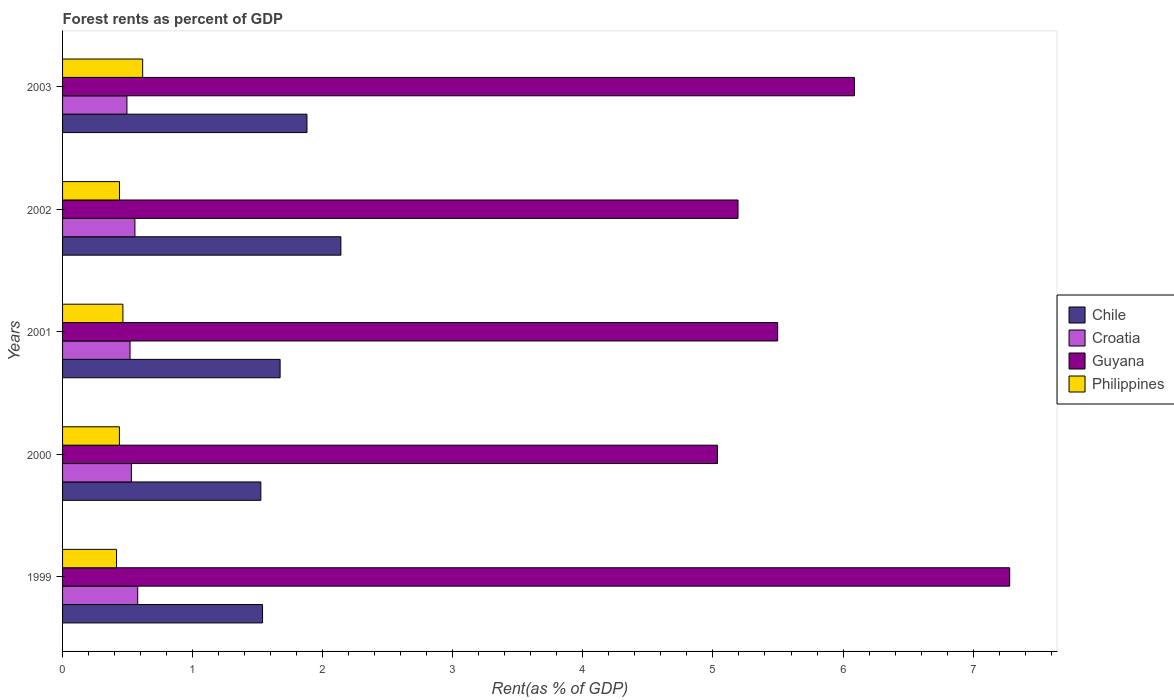Are the number of bars on each tick of the Y-axis equal?
Give a very brief answer. Yes. How many bars are there on the 3rd tick from the top?
Ensure brevity in your answer.  4. What is the forest rent in Philippines in 2002?
Your answer should be very brief. 0.44. Across all years, what is the maximum forest rent in Philippines?
Your answer should be very brief. 0.62. Across all years, what is the minimum forest rent in Philippines?
Your answer should be compact. 0.41. What is the total forest rent in Philippines in the graph?
Ensure brevity in your answer.  2.37. What is the difference between the forest rent in Chile in 2001 and that in 2003?
Offer a terse response. -0.21. What is the difference between the forest rent in Philippines in 2000 and the forest rent in Croatia in 2003?
Your answer should be very brief. -0.06. What is the average forest rent in Guyana per year?
Provide a succinct answer. 5.82. In the year 2000, what is the difference between the forest rent in Chile and forest rent in Philippines?
Your answer should be compact. 1.09. What is the ratio of the forest rent in Philippines in 2000 to that in 2001?
Provide a short and direct response. 0.94. Is the forest rent in Philippines in 2000 less than that in 2001?
Your response must be concise. Yes. Is the difference between the forest rent in Chile in 2000 and 2001 greater than the difference between the forest rent in Philippines in 2000 and 2001?
Give a very brief answer. No. What is the difference between the highest and the second highest forest rent in Guyana?
Give a very brief answer. 1.19. What is the difference between the highest and the lowest forest rent in Guyana?
Offer a very short reply. 2.25. In how many years, is the forest rent in Chile greater than the average forest rent in Chile taken over all years?
Give a very brief answer. 2. What does the 1st bar from the top in 2003 represents?
Your answer should be compact. Philippines. What does the 1st bar from the bottom in 2000 represents?
Offer a terse response. Chile. How many bars are there?
Your answer should be very brief. 20. Are all the bars in the graph horizontal?
Your answer should be very brief. Yes. How many years are there in the graph?
Your answer should be very brief. 5. What is the difference between two consecutive major ticks on the X-axis?
Provide a succinct answer. 1. How are the legend labels stacked?
Keep it short and to the point. Vertical. What is the title of the graph?
Your answer should be very brief. Forest rents as percent of GDP. Does "Lesotho" appear as one of the legend labels in the graph?
Provide a succinct answer. No. What is the label or title of the X-axis?
Provide a succinct answer. Rent(as % of GDP). What is the label or title of the Y-axis?
Make the answer very short. Years. What is the Rent(as % of GDP) in Chile in 1999?
Make the answer very short. 1.54. What is the Rent(as % of GDP) in Croatia in 1999?
Make the answer very short. 0.58. What is the Rent(as % of GDP) in Guyana in 1999?
Keep it short and to the point. 7.28. What is the Rent(as % of GDP) in Philippines in 1999?
Offer a terse response. 0.41. What is the Rent(as % of GDP) of Chile in 2000?
Provide a short and direct response. 1.52. What is the Rent(as % of GDP) of Croatia in 2000?
Make the answer very short. 0.53. What is the Rent(as % of GDP) in Guyana in 2000?
Offer a very short reply. 5.03. What is the Rent(as % of GDP) in Philippines in 2000?
Provide a short and direct response. 0.44. What is the Rent(as % of GDP) of Chile in 2001?
Provide a short and direct response. 1.67. What is the Rent(as % of GDP) of Croatia in 2001?
Offer a very short reply. 0.52. What is the Rent(as % of GDP) in Guyana in 2001?
Offer a terse response. 5.5. What is the Rent(as % of GDP) in Philippines in 2001?
Provide a short and direct response. 0.46. What is the Rent(as % of GDP) in Chile in 2002?
Your response must be concise. 2.14. What is the Rent(as % of GDP) of Croatia in 2002?
Keep it short and to the point. 0.56. What is the Rent(as % of GDP) of Guyana in 2002?
Give a very brief answer. 5.19. What is the Rent(as % of GDP) of Philippines in 2002?
Ensure brevity in your answer.  0.44. What is the Rent(as % of GDP) of Chile in 2003?
Make the answer very short. 1.88. What is the Rent(as % of GDP) in Croatia in 2003?
Your answer should be compact. 0.49. What is the Rent(as % of GDP) of Guyana in 2003?
Make the answer very short. 6.09. What is the Rent(as % of GDP) of Philippines in 2003?
Offer a very short reply. 0.62. Across all years, what is the maximum Rent(as % of GDP) of Chile?
Keep it short and to the point. 2.14. Across all years, what is the maximum Rent(as % of GDP) of Croatia?
Provide a succinct answer. 0.58. Across all years, what is the maximum Rent(as % of GDP) in Guyana?
Your response must be concise. 7.28. Across all years, what is the maximum Rent(as % of GDP) of Philippines?
Offer a very short reply. 0.62. Across all years, what is the minimum Rent(as % of GDP) of Chile?
Your response must be concise. 1.52. Across all years, what is the minimum Rent(as % of GDP) of Croatia?
Provide a short and direct response. 0.49. Across all years, what is the minimum Rent(as % of GDP) in Guyana?
Offer a very short reply. 5.03. Across all years, what is the minimum Rent(as % of GDP) in Philippines?
Offer a very short reply. 0.41. What is the total Rent(as % of GDP) of Chile in the graph?
Your answer should be very brief. 8.75. What is the total Rent(as % of GDP) in Croatia in the graph?
Offer a terse response. 2.68. What is the total Rent(as % of GDP) of Guyana in the graph?
Ensure brevity in your answer.  29.09. What is the total Rent(as % of GDP) of Philippines in the graph?
Your response must be concise. 2.37. What is the difference between the Rent(as % of GDP) of Chile in 1999 and that in 2000?
Make the answer very short. 0.01. What is the difference between the Rent(as % of GDP) in Croatia in 1999 and that in 2000?
Keep it short and to the point. 0.05. What is the difference between the Rent(as % of GDP) of Guyana in 1999 and that in 2000?
Your answer should be very brief. 2.25. What is the difference between the Rent(as % of GDP) of Philippines in 1999 and that in 2000?
Your answer should be very brief. -0.02. What is the difference between the Rent(as % of GDP) of Chile in 1999 and that in 2001?
Offer a very short reply. -0.14. What is the difference between the Rent(as % of GDP) of Croatia in 1999 and that in 2001?
Your answer should be very brief. 0.06. What is the difference between the Rent(as % of GDP) of Guyana in 1999 and that in 2001?
Make the answer very short. 1.78. What is the difference between the Rent(as % of GDP) in Philippines in 1999 and that in 2001?
Offer a very short reply. -0.05. What is the difference between the Rent(as % of GDP) of Chile in 1999 and that in 2002?
Make the answer very short. -0.6. What is the difference between the Rent(as % of GDP) in Croatia in 1999 and that in 2002?
Provide a short and direct response. 0.02. What is the difference between the Rent(as % of GDP) of Guyana in 1999 and that in 2002?
Give a very brief answer. 2.09. What is the difference between the Rent(as % of GDP) in Philippines in 1999 and that in 2002?
Your answer should be very brief. -0.02. What is the difference between the Rent(as % of GDP) in Chile in 1999 and that in 2003?
Provide a succinct answer. -0.34. What is the difference between the Rent(as % of GDP) of Croatia in 1999 and that in 2003?
Your answer should be very brief. 0.08. What is the difference between the Rent(as % of GDP) of Guyana in 1999 and that in 2003?
Your answer should be very brief. 1.19. What is the difference between the Rent(as % of GDP) of Philippines in 1999 and that in 2003?
Keep it short and to the point. -0.2. What is the difference between the Rent(as % of GDP) of Chile in 2000 and that in 2001?
Make the answer very short. -0.15. What is the difference between the Rent(as % of GDP) of Croatia in 2000 and that in 2001?
Ensure brevity in your answer.  0.01. What is the difference between the Rent(as % of GDP) in Guyana in 2000 and that in 2001?
Give a very brief answer. -0.46. What is the difference between the Rent(as % of GDP) in Philippines in 2000 and that in 2001?
Make the answer very short. -0.03. What is the difference between the Rent(as % of GDP) of Chile in 2000 and that in 2002?
Your answer should be compact. -0.62. What is the difference between the Rent(as % of GDP) of Croatia in 2000 and that in 2002?
Ensure brevity in your answer.  -0.03. What is the difference between the Rent(as % of GDP) of Guyana in 2000 and that in 2002?
Offer a very short reply. -0.16. What is the difference between the Rent(as % of GDP) of Philippines in 2000 and that in 2002?
Your response must be concise. -0. What is the difference between the Rent(as % of GDP) of Chile in 2000 and that in 2003?
Give a very brief answer. -0.35. What is the difference between the Rent(as % of GDP) in Croatia in 2000 and that in 2003?
Keep it short and to the point. 0.03. What is the difference between the Rent(as % of GDP) in Guyana in 2000 and that in 2003?
Your answer should be very brief. -1.05. What is the difference between the Rent(as % of GDP) in Philippines in 2000 and that in 2003?
Your response must be concise. -0.18. What is the difference between the Rent(as % of GDP) in Chile in 2001 and that in 2002?
Your answer should be compact. -0.47. What is the difference between the Rent(as % of GDP) of Croatia in 2001 and that in 2002?
Offer a terse response. -0.04. What is the difference between the Rent(as % of GDP) in Guyana in 2001 and that in 2002?
Give a very brief answer. 0.3. What is the difference between the Rent(as % of GDP) of Philippines in 2001 and that in 2002?
Offer a very short reply. 0.03. What is the difference between the Rent(as % of GDP) in Chile in 2001 and that in 2003?
Make the answer very short. -0.21. What is the difference between the Rent(as % of GDP) in Croatia in 2001 and that in 2003?
Give a very brief answer. 0.02. What is the difference between the Rent(as % of GDP) in Guyana in 2001 and that in 2003?
Keep it short and to the point. -0.59. What is the difference between the Rent(as % of GDP) in Philippines in 2001 and that in 2003?
Your answer should be very brief. -0.15. What is the difference between the Rent(as % of GDP) in Chile in 2002 and that in 2003?
Provide a short and direct response. 0.26. What is the difference between the Rent(as % of GDP) in Croatia in 2002 and that in 2003?
Provide a short and direct response. 0.06. What is the difference between the Rent(as % of GDP) in Guyana in 2002 and that in 2003?
Make the answer very short. -0.89. What is the difference between the Rent(as % of GDP) of Philippines in 2002 and that in 2003?
Keep it short and to the point. -0.18. What is the difference between the Rent(as % of GDP) in Chile in 1999 and the Rent(as % of GDP) in Croatia in 2000?
Make the answer very short. 1.01. What is the difference between the Rent(as % of GDP) of Chile in 1999 and the Rent(as % of GDP) of Guyana in 2000?
Make the answer very short. -3.5. What is the difference between the Rent(as % of GDP) of Chile in 1999 and the Rent(as % of GDP) of Philippines in 2000?
Offer a terse response. 1.1. What is the difference between the Rent(as % of GDP) in Croatia in 1999 and the Rent(as % of GDP) in Guyana in 2000?
Provide a short and direct response. -4.46. What is the difference between the Rent(as % of GDP) in Croatia in 1999 and the Rent(as % of GDP) in Philippines in 2000?
Your answer should be compact. 0.14. What is the difference between the Rent(as % of GDP) in Guyana in 1999 and the Rent(as % of GDP) in Philippines in 2000?
Offer a very short reply. 6.84. What is the difference between the Rent(as % of GDP) of Chile in 1999 and the Rent(as % of GDP) of Croatia in 2001?
Ensure brevity in your answer.  1.02. What is the difference between the Rent(as % of GDP) in Chile in 1999 and the Rent(as % of GDP) in Guyana in 2001?
Make the answer very short. -3.96. What is the difference between the Rent(as % of GDP) of Chile in 1999 and the Rent(as % of GDP) of Philippines in 2001?
Give a very brief answer. 1.07. What is the difference between the Rent(as % of GDP) of Croatia in 1999 and the Rent(as % of GDP) of Guyana in 2001?
Your answer should be very brief. -4.92. What is the difference between the Rent(as % of GDP) of Croatia in 1999 and the Rent(as % of GDP) of Philippines in 2001?
Make the answer very short. 0.11. What is the difference between the Rent(as % of GDP) in Guyana in 1999 and the Rent(as % of GDP) in Philippines in 2001?
Keep it short and to the point. 6.82. What is the difference between the Rent(as % of GDP) in Chile in 1999 and the Rent(as % of GDP) in Croatia in 2002?
Offer a terse response. 0.98. What is the difference between the Rent(as % of GDP) in Chile in 1999 and the Rent(as % of GDP) in Guyana in 2002?
Offer a very short reply. -3.66. What is the difference between the Rent(as % of GDP) of Chile in 1999 and the Rent(as % of GDP) of Philippines in 2002?
Offer a very short reply. 1.1. What is the difference between the Rent(as % of GDP) in Croatia in 1999 and the Rent(as % of GDP) in Guyana in 2002?
Provide a short and direct response. -4.61. What is the difference between the Rent(as % of GDP) in Croatia in 1999 and the Rent(as % of GDP) in Philippines in 2002?
Provide a succinct answer. 0.14. What is the difference between the Rent(as % of GDP) in Guyana in 1999 and the Rent(as % of GDP) in Philippines in 2002?
Your answer should be very brief. 6.84. What is the difference between the Rent(as % of GDP) in Chile in 1999 and the Rent(as % of GDP) in Croatia in 2003?
Give a very brief answer. 1.04. What is the difference between the Rent(as % of GDP) in Chile in 1999 and the Rent(as % of GDP) in Guyana in 2003?
Ensure brevity in your answer.  -4.55. What is the difference between the Rent(as % of GDP) of Chile in 1999 and the Rent(as % of GDP) of Philippines in 2003?
Your answer should be compact. 0.92. What is the difference between the Rent(as % of GDP) of Croatia in 1999 and the Rent(as % of GDP) of Guyana in 2003?
Your response must be concise. -5.51. What is the difference between the Rent(as % of GDP) of Croatia in 1999 and the Rent(as % of GDP) of Philippines in 2003?
Offer a very short reply. -0.04. What is the difference between the Rent(as % of GDP) of Guyana in 1999 and the Rent(as % of GDP) of Philippines in 2003?
Offer a very short reply. 6.67. What is the difference between the Rent(as % of GDP) in Chile in 2000 and the Rent(as % of GDP) in Croatia in 2001?
Your answer should be compact. 1.01. What is the difference between the Rent(as % of GDP) in Chile in 2000 and the Rent(as % of GDP) in Guyana in 2001?
Provide a succinct answer. -3.97. What is the difference between the Rent(as % of GDP) of Chile in 2000 and the Rent(as % of GDP) of Philippines in 2001?
Your response must be concise. 1.06. What is the difference between the Rent(as % of GDP) of Croatia in 2000 and the Rent(as % of GDP) of Guyana in 2001?
Offer a terse response. -4.97. What is the difference between the Rent(as % of GDP) in Croatia in 2000 and the Rent(as % of GDP) in Philippines in 2001?
Provide a succinct answer. 0.07. What is the difference between the Rent(as % of GDP) in Guyana in 2000 and the Rent(as % of GDP) in Philippines in 2001?
Offer a very short reply. 4.57. What is the difference between the Rent(as % of GDP) in Chile in 2000 and the Rent(as % of GDP) in Croatia in 2002?
Provide a succinct answer. 0.97. What is the difference between the Rent(as % of GDP) of Chile in 2000 and the Rent(as % of GDP) of Guyana in 2002?
Provide a succinct answer. -3.67. What is the difference between the Rent(as % of GDP) in Chile in 2000 and the Rent(as % of GDP) in Philippines in 2002?
Offer a terse response. 1.09. What is the difference between the Rent(as % of GDP) in Croatia in 2000 and the Rent(as % of GDP) in Guyana in 2002?
Your answer should be very brief. -4.66. What is the difference between the Rent(as % of GDP) of Croatia in 2000 and the Rent(as % of GDP) of Philippines in 2002?
Ensure brevity in your answer.  0.09. What is the difference between the Rent(as % of GDP) in Guyana in 2000 and the Rent(as % of GDP) in Philippines in 2002?
Your answer should be very brief. 4.6. What is the difference between the Rent(as % of GDP) of Chile in 2000 and the Rent(as % of GDP) of Croatia in 2003?
Provide a short and direct response. 1.03. What is the difference between the Rent(as % of GDP) in Chile in 2000 and the Rent(as % of GDP) in Guyana in 2003?
Your answer should be compact. -4.56. What is the difference between the Rent(as % of GDP) of Chile in 2000 and the Rent(as % of GDP) of Philippines in 2003?
Your answer should be very brief. 0.91. What is the difference between the Rent(as % of GDP) in Croatia in 2000 and the Rent(as % of GDP) in Guyana in 2003?
Ensure brevity in your answer.  -5.56. What is the difference between the Rent(as % of GDP) of Croatia in 2000 and the Rent(as % of GDP) of Philippines in 2003?
Your response must be concise. -0.09. What is the difference between the Rent(as % of GDP) of Guyana in 2000 and the Rent(as % of GDP) of Philippines in 2003?
Your answer should be very brief. 4.42. What is the difference between the Rent(as % of GDP) of Chile in 2001 and the Rent(as % of GDP) of Croatia in 2002?
Provide a succinct answer. 1.12. What is the difference between the Rent(as % of GDP) in Chile in 2001 and the Rent(as % of GDP) in Guyana in 2002?
Offer a terse response. -3.52. What is the difference between the Rent(as % of GDP) in Chile in 2001 and the Rent(as % of GDP) in Philippines in 2002?
Make the answer very short. 1.23. What is the difference between the Rent(as % of GDP) of Croatia in 2001 and the Rent(as % of GDP) of Guyana in 2002?
Offer a terse response. -4.67. What is the difference between the Rent(as % of GDP) in Croatia in 2001 and the Rent(as % of GDP) in Philippines in 2002?
Provide a succinct answer. 0.08. What is the difference between the Rent(as % of GDP) in Guyana in 2001 and the Rent(as % of GDP) in Philippines in 2002?
Make the answer very short. 5.06. What is the difference between the Rent(as % of GDP) in Chile in 2001 and the Rent(as % of GDP) in Croatia in 2003?
Give a very brief answer. 1.18. What is the difference between the Rent(as % of GDP) of Chile in 2001 and the Rent(as % of GDP) of Guyana in 2003?
Provide a short and direct response. -4.41. What is the difference between the Rent(as % of GDP) of Chile in 2001 and the Rent(as % of GDP) of Philippines in 2003?
Your answer should be compact. 1.06. What is the difference between the Rent(as % of GDP) in Croatia in 2001 and the Rent(as % of GDP) in Guyana in 2003?
Provide a short and direct response. -5.57. What is the difference between the Rent(as % of GDP) of Croatia in 2001 and the Rent(as % of GDP) of Philippines in 2003?
Give a very brief answer. -0.1. What is the difference between the Rent(as % of GDP) of Guyana in 2001 and the Rent(as % of GDP) of Philippines in 2003?
Provide a short and direct response. 4.88. What is the difference between the Rent(as % of GDP) of Chile in 2002 and the Rent(as % of GDP) of Croatia in 2003?
Offer a terse response. 1.64. What is the difference between the Rent(as % of GDP) of Chile in 2002 and the Rent(as % of GDP) of Guyana in 2003?
Keep it short and to the point. -3.95. What is the difference between the Rent(as % of GDP) in Chile in 2002 and the Rent(as % of GDP) in Philippines in 2003?
Your response must be concise. 1.52. What is the difference between the Rent(as % of GDP) in Croatia in 2002 and the Rent(as % of GDP) in Guyana in 2003?
Ensure brevity in your answer.  -5.53. What is the difference between the Rent(as % of GDP) of Croatia in 2002 and the Rent(as % of GDP) of Philippines in 2003?
Make the answer very short. -0.06. What is the difference between the Rent(as % of GDP) in Guyana in 2002 and the Rent(as % of GDP) in Philippines in 2003?
Provide a succinct answer. 4.58. What is the average Rent(as % of GDP) of Chile per year?
Make the answer very short. 1.75. What is the average Rent(as % of GDP) in Croatia per year?
Offer a very short reply. 0.54. What is the average Rent(as % of GDP) of Guyana per year?
Your answer should be very brief. 5.82. What is the average Rent(as % of GDP) in Philippines per year?
Your answer should be very brief. 0.47. In the year 1999, what is the difference between the Rent(as % of GDP) in Chile and Rent(as % of GDP) in Croatia?
Ensure brevity in your answer.  0.96. In the year 1999, what is the difference between the Rent(as % of GDP) in Chile and Rent(as % of GDP) in Guyana?
Your answer should be compact. -5.74. In the year 1999, what is the difference between the Rent(as % of GDP) in Chile and Rent(as % of GDP) in Philippines?
Give a very brief answer. 1.12. In the year 1999, what is the difference between the Rent(as % of GDP) of Croatia and Rent(as % of GDP) of Guyana?
Ensure brevity in your answer.  -6.7. In the year 1999, what is the difference between the Rent(as % of GDP) in Croatia and Rent(as % of GDP) in Philippines?
Your answer should be very brief. 0.16. In the year 1999, what is the difference between the Rent(as % of GDP) in Guyana and Rent(as % of GDP) in Philippines?
Your answer should be compact. 6.87. In the year 2000, what is the difference between the Rent(as % of GDP) of Chile and Rent(as % of GDP) of Guyana?
Give a very brief answer. -3.51. In the year 2000, what is the difference between the Rent(as % of GDP) of Chile and Rent(as % of GDP) of Philippines?
Provide a succinct answer. 1.09. In the year 2000, what is the difference between the Rent(as % of GDP) of Croatia and Rent(as % of GDP) of Guyana?
Make the answer very short. -4.51. In the year 2000, what is the difference between the Rent(as % of GDP) of Croatia and Rent(as % of GDP) of Philippines?
Make the answer very short. 0.09. In the year 2000, what is the difference between the Rent(as % of GDP) of Guyana and Rent(as % of GDP) of Philippines?
Provide a succinct answer. 4.6. In the year 2001, what is the difference between the Rent(as % of GDP) in Chile and Rent(as % of GDP) in Croatia?
Offer a very short reply. 1.15. In the year 2001, what is the difference between the Rent(as % of GDP) in Chile and Rent(as % of GDP) in Guyana?
Your response must be concise. -3.83. In the year 2001, what is the difference between the Rent(as % of GDP) in Chile and Rent(as % of GDP) in Philippines?
Your response must be concise. 1.21. In the year 2001, what is the difference between the Rent(as % of GDP) in Croatia and Rent(as % of GDP) in Guyana?
Provide a short and direct response. -4.98. In the year 2001, what is the difference between the Rent(as % of GDP) of Croatia and Rent(as % of GDP) of Philippines?
Give a very brief answer. 0.05. In the year 2001, what is the difference between the Rent(as % of GDP) in Guyana and Rent(as % of GDP) in Philippines?
Keep it short and to the point. 5.03. In the year 2002, what is the difference between the Rent(as % of GDP) in Chile and Rent(as % of GDP) in Croatia?
Your answer should be very brief. 1.58. In the year 2002, what is the difference between the Rent(as % of GDP) in Chile and Rent(as % of GDP) in Guyana?
Provide a short and direct response. -3.05. In the year 2002, what is the difference between the Rent(as % of GDP) in Chile and Rent(as % of GDP) in Philippines?
Keep it short and to the point. 1.7. In the year 2002, what is the difference between the Rent(as % of GDP) of Croatia and Rent(as % of GDP) of Guyana?
Your answer should be compact. -4.64. In the year 2002, what is the difference between the Rent(as % of GDP) in Croatia and Rent(as % of GDP) in Philippines?
Give a very brief answer. 0.12. In the year 2002, what is the difference between the Rent(as % of GDP) in Guyana and Rent(as % of GDP) in Philippines?
Your answer should be very brief. 4.75. In the year 2003, what is the difference between the Rent(as % of GDP) of Chile and Rent(as % of GDP) of Croatia?
Provide a short and direct response. 1.38. In the year 2003, what is the difference between the Rent(as % of GDP) of Chile and Rent(as % of GDP) of Guyana?
Make the answer very short. -4.21. In the year 2003, what is the difference between the Rent(as % of GDP) of Chile and Rent(as % of GDP) of Philippines?
Ensure brevity in your answer.  1.26. In the year 2003, what is the difference between the Rent(as % of GDP) in Croatia and Rent(as % of GDP) in Guyana?
Give a very brief answer. -5.59. In the year 2003, what is the difference between the Rent(as % of GDP) in Croatia and Rent(as % of GDP) in Philippines?
Provide a succinct answer. -0.12. In the year 2003, what is the difference between the Rent(as % of GDP) in Guyana and Rent(as % of GDP) in Philippines?
Offer a terse response. 5.47. What is the ratio of the Rent(as % of GDP) in Chile in 1999 to that in 2000?
Ensure brevity in your answer.  1.01. What is the ratio of the Rent(as % of GDP) of Croatia in 1999 to that in 2000?
Your answer should be compact. 1.09. What is the ratio of the Rent(as % of GDP) of Guyana in 1999 to that in 2000?
Keep it short and to the point. 1.45. What is the ratio of the Rent(as % of GDP) of Philippines in 1999 to that in 2000?
Offer a terse response. 0.95. What is the ratio of the Rent(as % of GDP) in Chile in 1999 to that in 2001?
Your response must be concise. 0.92. What is the ratio of the Rent(as % of GDP) in Croatia in 1999 to that in 2001?
Keep it short and to the point. 1.11. What is the ratio of the Rent(as % of GDP) in Guyana in 1999 to that in 2001?
Ensure brevity in your answer.  1.32. What is the ratio of the Rent(as % of GDP) in Philippines in 1999 to that in 2001?
Offer a very short reply. 0.89. What is the ratio of the Rent(as % of GDP) in Chile in 1999 to that in 2002?
Offer a very short reply. 0.72. What is the ratio of the Rent(as % of GDP) in Croatia in 1999 to that in 2002?
Provide a short and direct response. 1.04. What is the ratio of the Rent(as % of GDP) of Guyana in 1999 to that in 2002?
Your answer should be very brief. 1.4. What is the ratio of the Rent(as % of GDP) of Philippines in 1999 to that in 2002?
Provide a succinct answer. 0.95. What is the ratio of the Rent(as % of GDP) of Chile in 1999 to that in 2003?
Ensure brevity in your answer.  0.82. What is the ratio of the Rent(as % of GDP) in Croatia in 1999 to that in 2003?
Give a very brief answer. 1.17. What is the ratio of the Rent(as % of GDP) in Guyana in 1999 to that in 2003?
Ensure brevity in your answer.  1.2. What is the ratio of the Rent(as % of GDP) in Philippines in 1999 to that in 2003?
Ensure brevity in your answer.  0.67. What is the ratio of the Rent(as % of GDP) in Chile in 2000 to that in 2001?
Make the answer very short. 0.91. What is the ratio of the Rent(as % of GDP) in Croatia in 2000 to that in 2001?
Provide a succinct answer. 1.02. What is the ratio of the Rent(as % of GDP) of Guyana in 2000 to that in 2001?
Your response must be concise. 0.92. What is the ratio of the Rent(as % of GDP) in Philippines in 2000 to that in 2001?
Ensure brevity in your answer.  0.94. What is the ratio of the Rent(as % of GDP) in Chile in 2000 to that in 2002?
Keep it short and to the point. 0.71. What is the ratio of the Rent(as % of GDP) of Croatia in 2000 to that in 2002?
Provide a succinct answer. 0.95. What is the ratio of the Rent(as % of GDP) in Guyana in 2000 to that in 2002?
Give a very brief answer. 0.97. What is the ratio of the Rent(as % of GDP) of Chile in 2000 to that in 2003?
Give a very brief answer. 0.81. What is the ratio of the Rent(as % of GDP) in Croatia in 2000 to that in 2003?
Offer a terse response. 1.07. What is the ratio of the Rent(as % of GDP) in Guyana in 2000 to that in 2003?
Provide a short and direct response. 0.83. What is the ratio of the Rent(as % of GDP) of Philippines in 2000 to that in 2003?
Provide a short and direct response. 0.71. What is the ratio of the Rent(as % of GDP) of Chile in 2001 to that in 2002?
Your answer should be compact. 0.78. What is the ratio of the Rent(as % of GDP) in Croatia in 2001 to that in 2002?
Make the answer very short. 0.93. What is the ratio of the Rent(as % of GDP) in Guyana in 2001 to that in 2002?
Your answer should be compact. 1.06. What is the ratio of the Rent(as % of GDP) in Philippines in 2001 to that in 2002?
Give a very brief answer. 1.06. What is the ratio of the Rent(as % of GDP) of Chile in 2001 to that in 2003?
Keep it short and to the point. 0.89. What is the ratio of the Rent(as % of GDP) in Croatia in 2001 to that in 2003?
Your response must be concise. 1.05. What is the ratio of the Rent(as % of GDP) in Guyana in 2001 to that in 2003?
Offer a terse response. 0.9. What is the ratio of the Rent(as % of GDP) in Philippines in 2001 to that in 2003?
Provide a succinct answer. 0.75. What is the ratio of the Rent(as % of GDP) of Chile in 2002 to that in 2003?
Keep it short and to the point. 1.14. What is the ratio of the Rent(as % of GDP) of Croatia in 2002 to that in 2003?
Your answer should be very brief. 1.12. What is the ratio of the Rent(as % of GDP) in Guyana in 2002 to that in 2003?
Give a very brief answer. 0.85. What is the ratio of the Rent(as % of GDP) in Philippines in 2002 to that in 2003?
Offer a terse response. 0.71. What is the difference between the highest and the second highest Rent(as % of GDP) of Chile?
Offer a very short reply. 0.26. What is the difference between the highest and the second highest Rent(as % of GDP) in Croatia?
Offer a terse response. 0.02. What is the difference between the highest and the second highest Rent(as % of GDP) of Guyana?
Keep it short and to the point. 1.19. What is the difference between the highest and the second highest Rent(as % of GDP) in Philippines?
Keep it short and to the point. 0.15. What is the difference between the highest and the lowest Rent(as % of GDP) in Chile?
Offer a very short reply. 0.62. What is the difference between the highest and the lowest Rent(as % of GDP) in Croatia?
Your response must be concise. 0.08. What is the difference between the highest and the lowest Rent(as % of GDP) in Guyana?
Provide a succinct answer. 2.25. What is the difference between the highest and the lowest Rent(as % of GDP) in Philippines?
Provide a succinct answer. 0.2. 